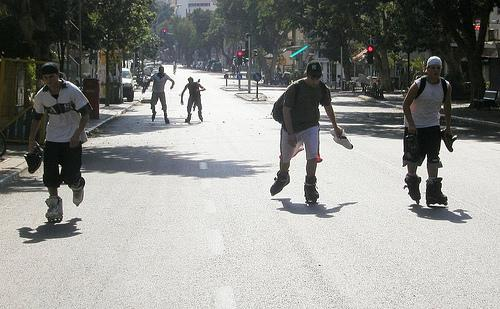What enables these people to go faster on the street? Please explain your reasoning. roller blades. They are on roller blades on the street. 